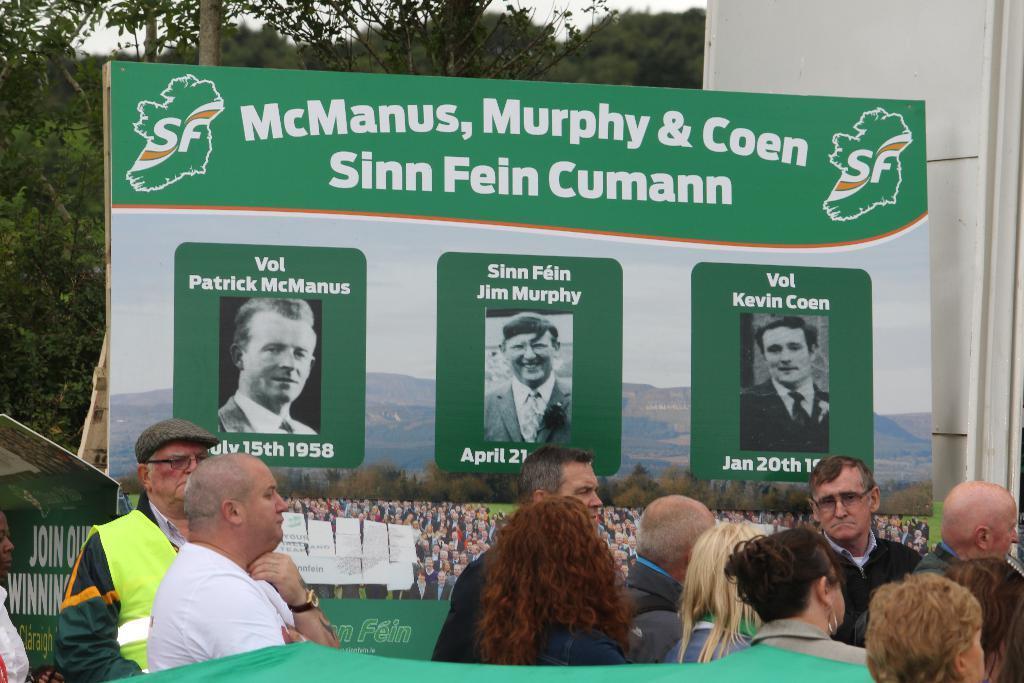Please provide a concise description of this image. In this image I can see people. Here I can see a board. On the board I can see pictures of people, mountain, the sky and something written on it. In the background I can see trees. 